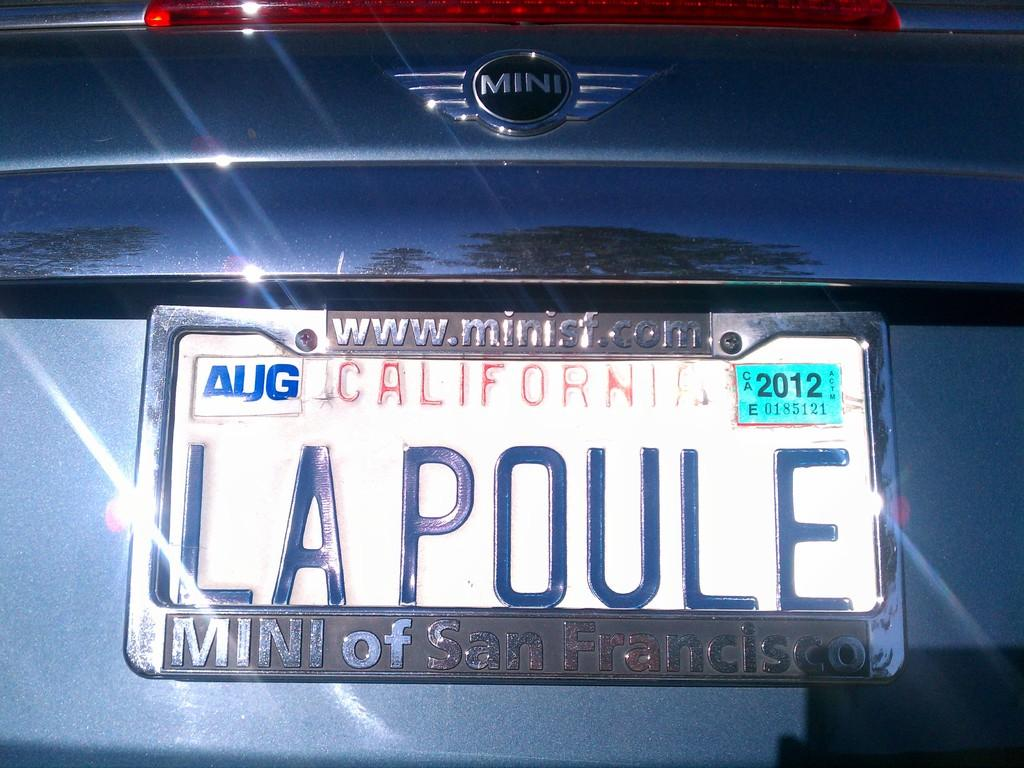<image>
Describe the image concisely. A Calafornia licence plate on a Mini reads LAPOULE. 